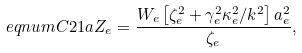Convert formula to latex. <formula><loc_0><loc_0><loc_500><loc_500>\ e q n u m { C 2 1 a } Z _ { e } = \frac { W _ { e } \left [ \zeta _ { e } ^ { 2 } + \gamma _ { e } ^ { 2 } \kappa _ { e } ^ { 2 } / k ^ { 2 } \right ] a _ { e } ^ { 2 } } { \zeta _ { e } } ,</formula> 